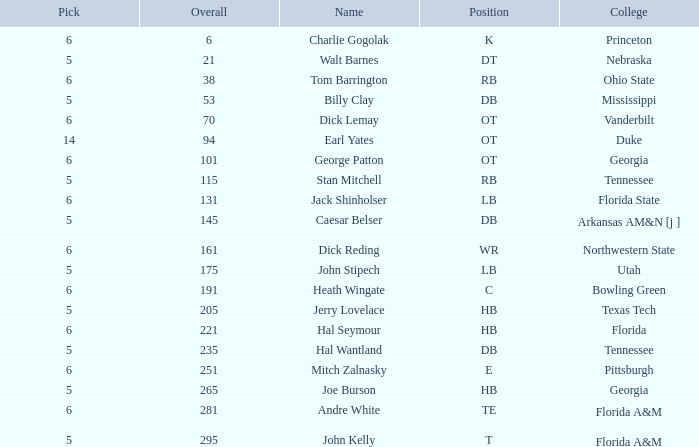What is the highest Pick, when Round is greater than 15, and when College is "Tennessee"? 5.0. 